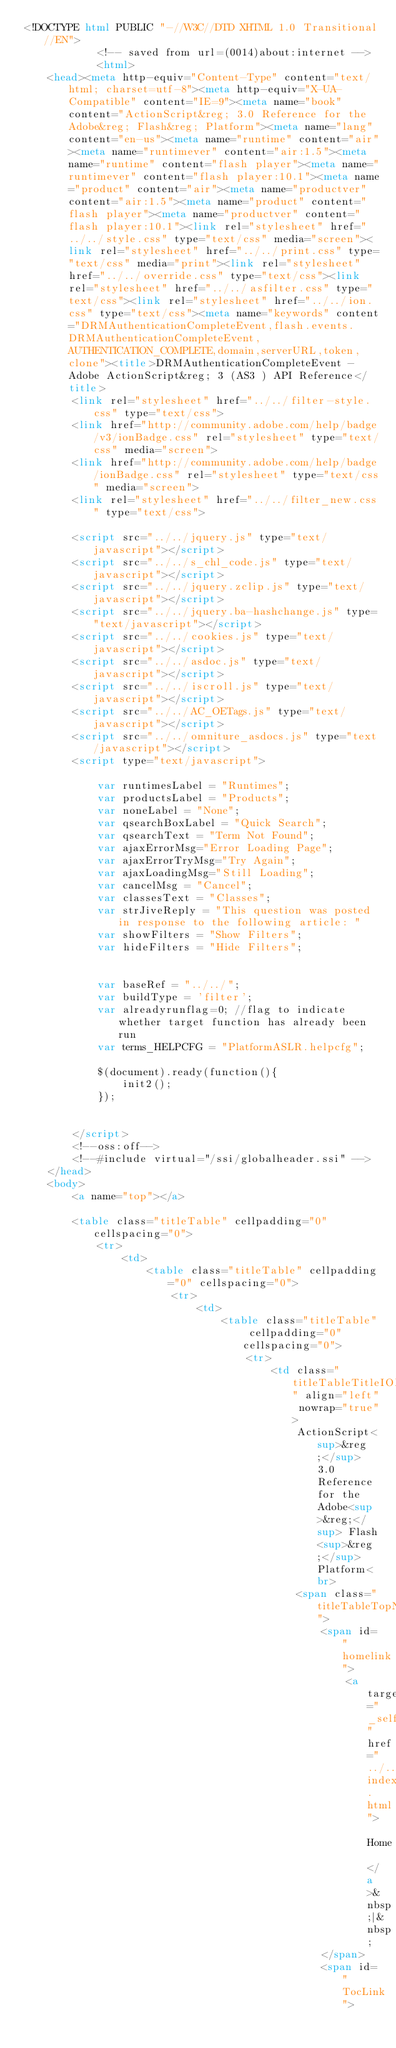<code> <loc_0><loc_0><loc_500><loc_500><_HTML_><!DOCTYPE html PUBLIC "-//W3C//DTD XHTML 1.0 Transitional//EN">
			<!-- saved from url=(0014)about:internet -->
			<html>
	<head><meta http-equiv="Content-Type" content="text/html; charset=utf-8"><meta http-equiv="X-UA-Compatible" content="IE=9"><meta name="book" content="ActionScript&reg; 3.0 Reference for the Adobe&reg; Flash&reg; Platform"><meta name="lang" content="en-us"><meta name="runtime" content="air"><meta name="runtimever" content="air:1.5"><meta name="runtime" content="flash player"><meta name="runtimever" content="flash player:10.1"><meta name="product" content="air"><meta name="productver" content="air:1.5"><meta name="product" content="flash player"><meta name="productver" content="flash player:10.1"><link rel="stylesheet" href="../../style.css" type="text/css" media="screen"><link rel="stylesheet" href="../../print.css" type="text/css" media="print"><link rel="stylesheet" href="../../override.css" type="text/css"><link rel="stylesheet" href="../../asfilter.css" type="text/css"><link rel="stylesheet" href="../../ion.css" type="text/css"><meta name="keywords" content="DRMAuthenticationCompleteEvent,flash.events.DRMAuthenticationCompleteEvent,AUTHENTICATION_COMPLETE,domain,serverURL,token,clone"><title>DRMAuthenticationCompleteEvent - Adobe ActionScript&reg; 3 (AS3 ) API Reference</title>
		<link rel="stylesheet" href="../../filter-style.css" type="text/css">
		<link href="http://community.adobe.com/help/badge/v3/ionBadge.css" rel="stylesheet" type="text/css" media="screen">
		<link href="http://community.adobe.com/help/badge/ionBadge.css" rel="stylesheet" type="text/css" media="screen">
		<link rel="stylesheet" href="../../filter_new.css" type="text/css">
			
		<script src="../../jquery.js" type="text/javascript"></script>
		<script src="../../s_chl_code.js" type="text/javascript"></script>
		<script src="../../jquery.zclip.js" type="text/javascript"></script>
		<script src="../../jquery.ba-hashchange.js" type="text/javascript"></script>
		<script src="../../cookies.js" type="text/javascript"></script>
		<script src="../../asdoc.js" type="text/javascript"></script>
		<script src="../../iscroll.js" type="text/javascript"></script>
		<script src="../../AC_OETags.js" type="text/javascript"></script>
		<script src="../../omniture_asdocs.js" type="text/javascript"></script>
		<script type="text/javascript">
		
			var runtimesLabel = "Runtimes";
			var productsLabel = "Products";
			var noneLabel = "None";
			var qsearchBoxLabel = "Quick Search";
			var qsearchText = "Term Not Found";
			var ajaxErrorMsg="Error Loading Page";
			var ajaxErrorTryMsg="Try Again";
			var ajaxLoadingMsg="Still Loading";
			var cancelMsg = "Cancel";
			var classesText = "Classes";
			var strJiveReply = "This question was posted in response to the following article: "
			var showFilters = "Show Filters";
			var hideFilters = "Hide Filters";
			
		
			var baseRef = "../../";
			var buildType = 'filter';
			var alreadyrunflag=0; //flag to indicate whether target function has already been run
			var terms_HELPCFG = "PlatformASLR.helpcfg";
			
			$(document).ready(function(){
				init2();
			});
			
		
		</script>
		<!--oss:off-->
		<!--#include virtual="/ssi/globalheader.ssi" -->
	</head>
	<body>
		<a name="top"></a>
		
		<table class="titleTable" cellpadding="0" cellspacing="0">
			<tr>
				<td>
					<table class="titleTable" cellpadding="0" cellspacing="0">
						<tr>
							<td>
								<table class="titleTable" cellpadding="0" cellspacing="0">
									<tr>
										<td class="titleTableTitleION" align="left" nowrap="true">
											ActionScript<sup>&reg;</sup> 3.0 Reference for the Adobe<sup>&reg;</sup> Flash<sup>&reg;</sup> Platform<br>
											<span class="titleTableTopNavION">
												<span id="homelink">
													<a target="_self" href="../../index.html"> Home </a>&nbsp;|&nbsp;
												</span>
												<span id="TocLink"></code> 